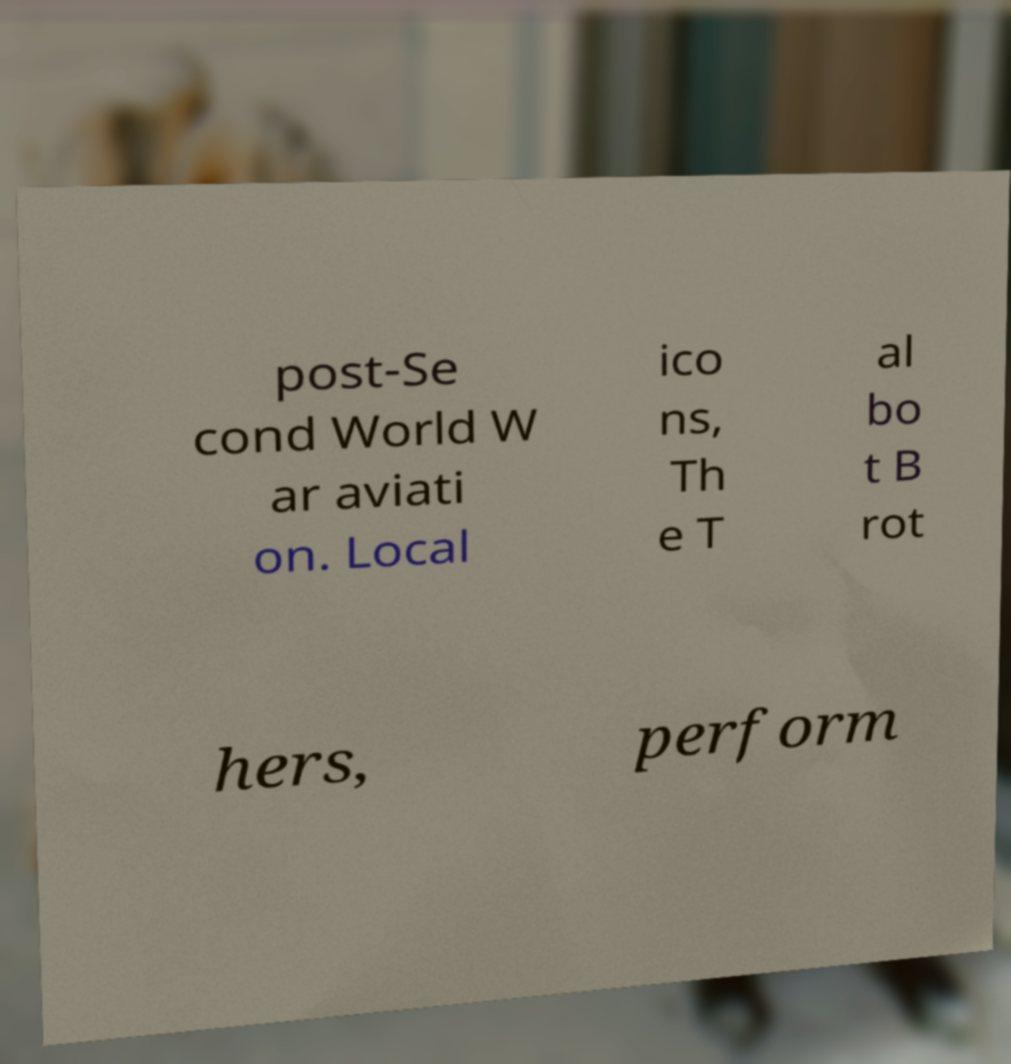Could you extract and type out the text from this image? post-Se cond World W ar aviati on. Local ico ns, Th e T al bo t B rot hers, perform 